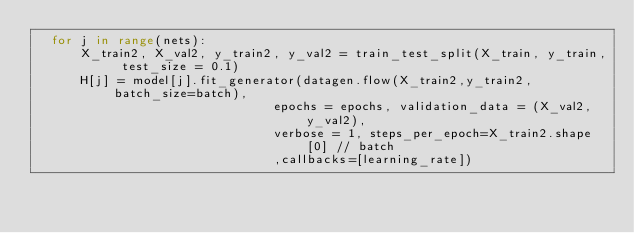Convert code to text. <code><loc_0><loc_0><loc_500><loc_500><_Python_>	for j in range(nets):
	    X_train2, X_val2, y_train2, y_val2 = train_test_split(X_train, y_train, test_size = 0.1)
	    H[j] = model[j].fit_generator(datagen.flow(X_train2,y_train2, batch_size=batch),
	                              epochs = epochs, validation_data = (X_val2,y_val2),
	                              verbose = 1, steps_per_epoch=X_train2.shape[0] // batch
	                              ,callbacks=[learning_rate])
</code> 